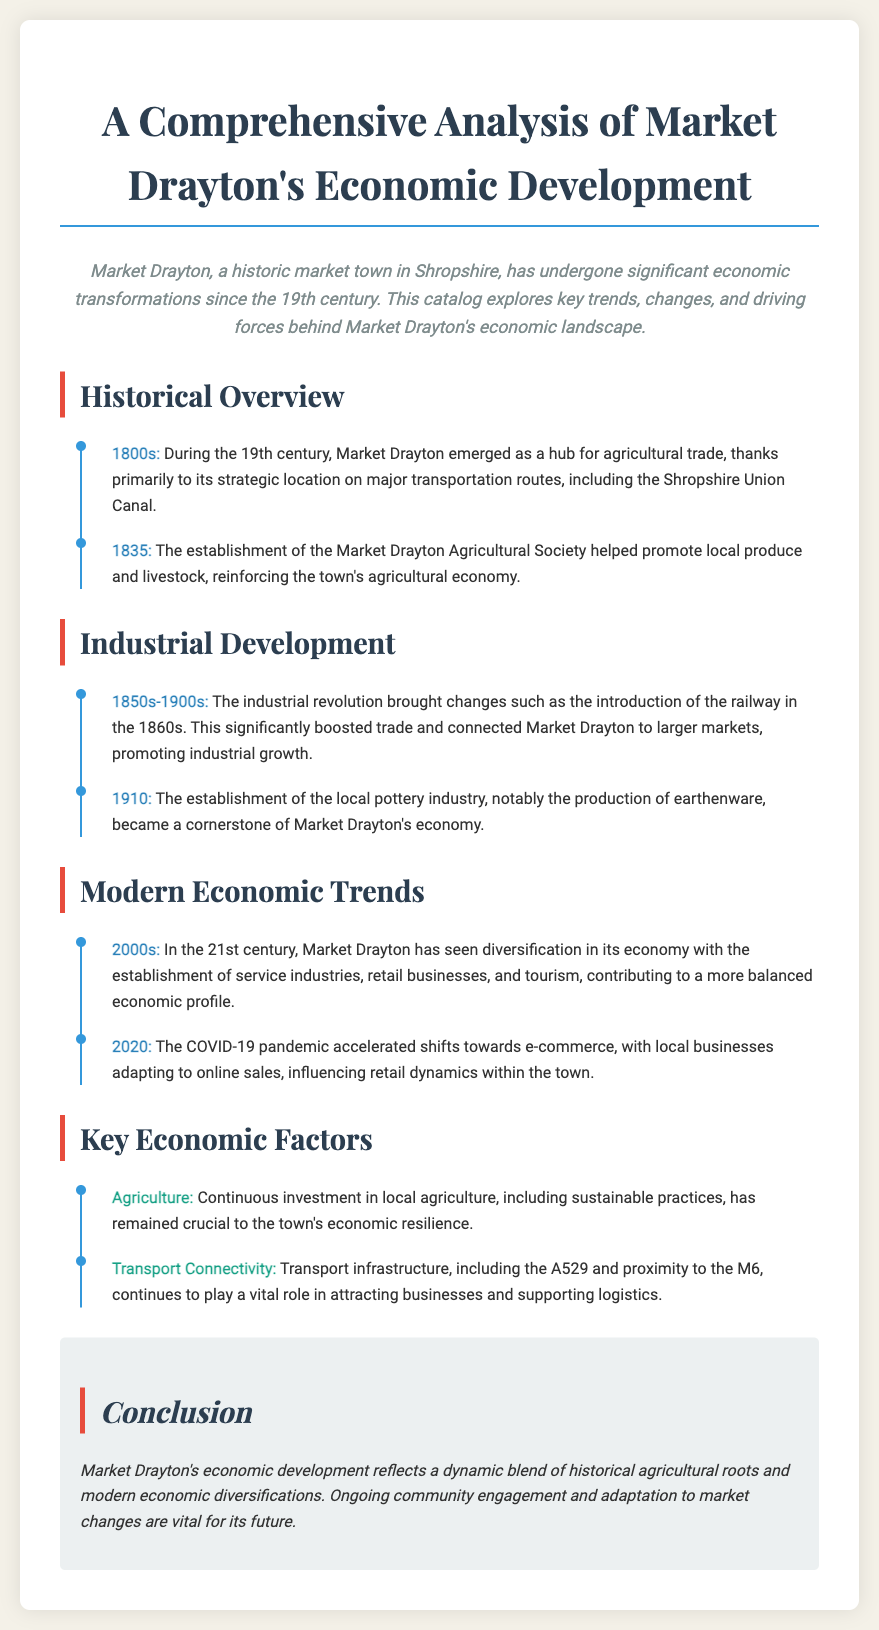What was the primary economic activity in 1800s Market Drayton? The document states that during the 19th century, Market Drayton emerged as a hub for agricultural trade.
Answer: Agricultural trade What year was the Market Drayton Agricultural Society established? The document specifies that the Agricultural Society was established in 1835.
Answer: 1835 What significant infrastructure was introduced in the 1860s? The document indicates that the introduction of the railway in the 1860s significantly boosted trade.
Answer: Railway In which year did the local pottery industry become established? According to the document, the pottery industry was established in 1910.
Answer: 1910 What economic change occurred in the 2000s? The document mentions that Market Drayton saw diversification in its economy during the 21st century.
Answer: Diversification What was one key factor contributing to Market Drayton's economy? The document identifies continuous investment in local agriculture as a crucial economic factor.
Answer: Agriculture What role does transport connectivity play in Market Drayton's economy? Transport infrastructure is stated as vital in attracting businesses and supporting logistics.
Answer: Vital role What has accelerated shifts towards e-commerce? The document highlights that the COVID-19 pandemic accelerated these shifts.
Answer: COVID-19 pandemic 